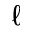Convert formula to latex. <formula><loc_0><loc_0><loc_500><loc_500>\ell</formula> 